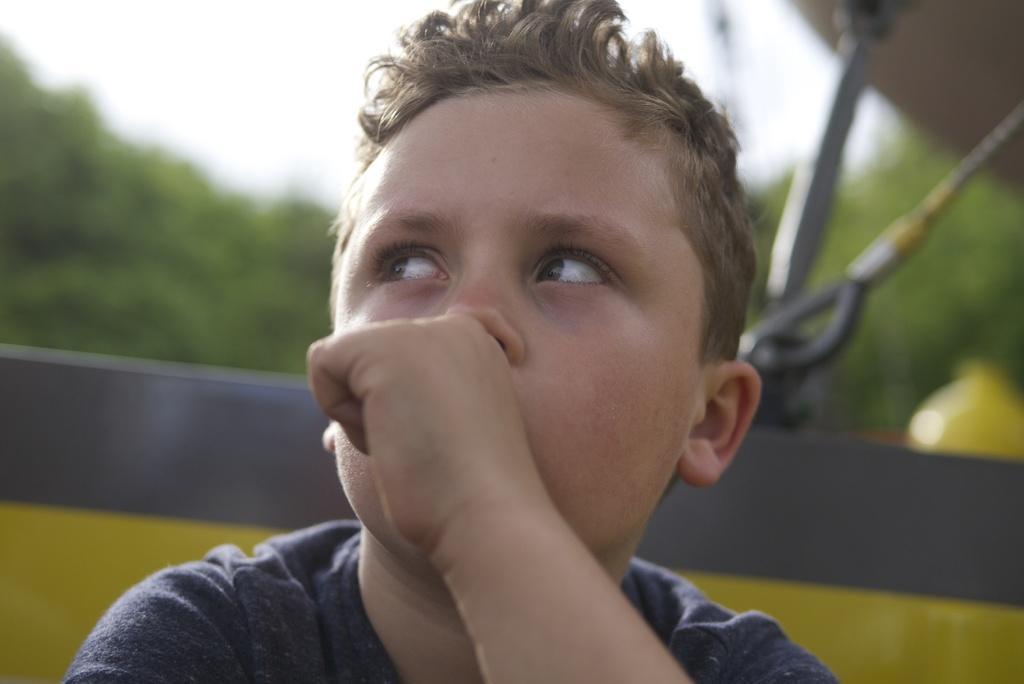Can you describe this image briefly? In this image in front there is a boy. Behind him there is some object. In the background of the image there are trees and sky. 